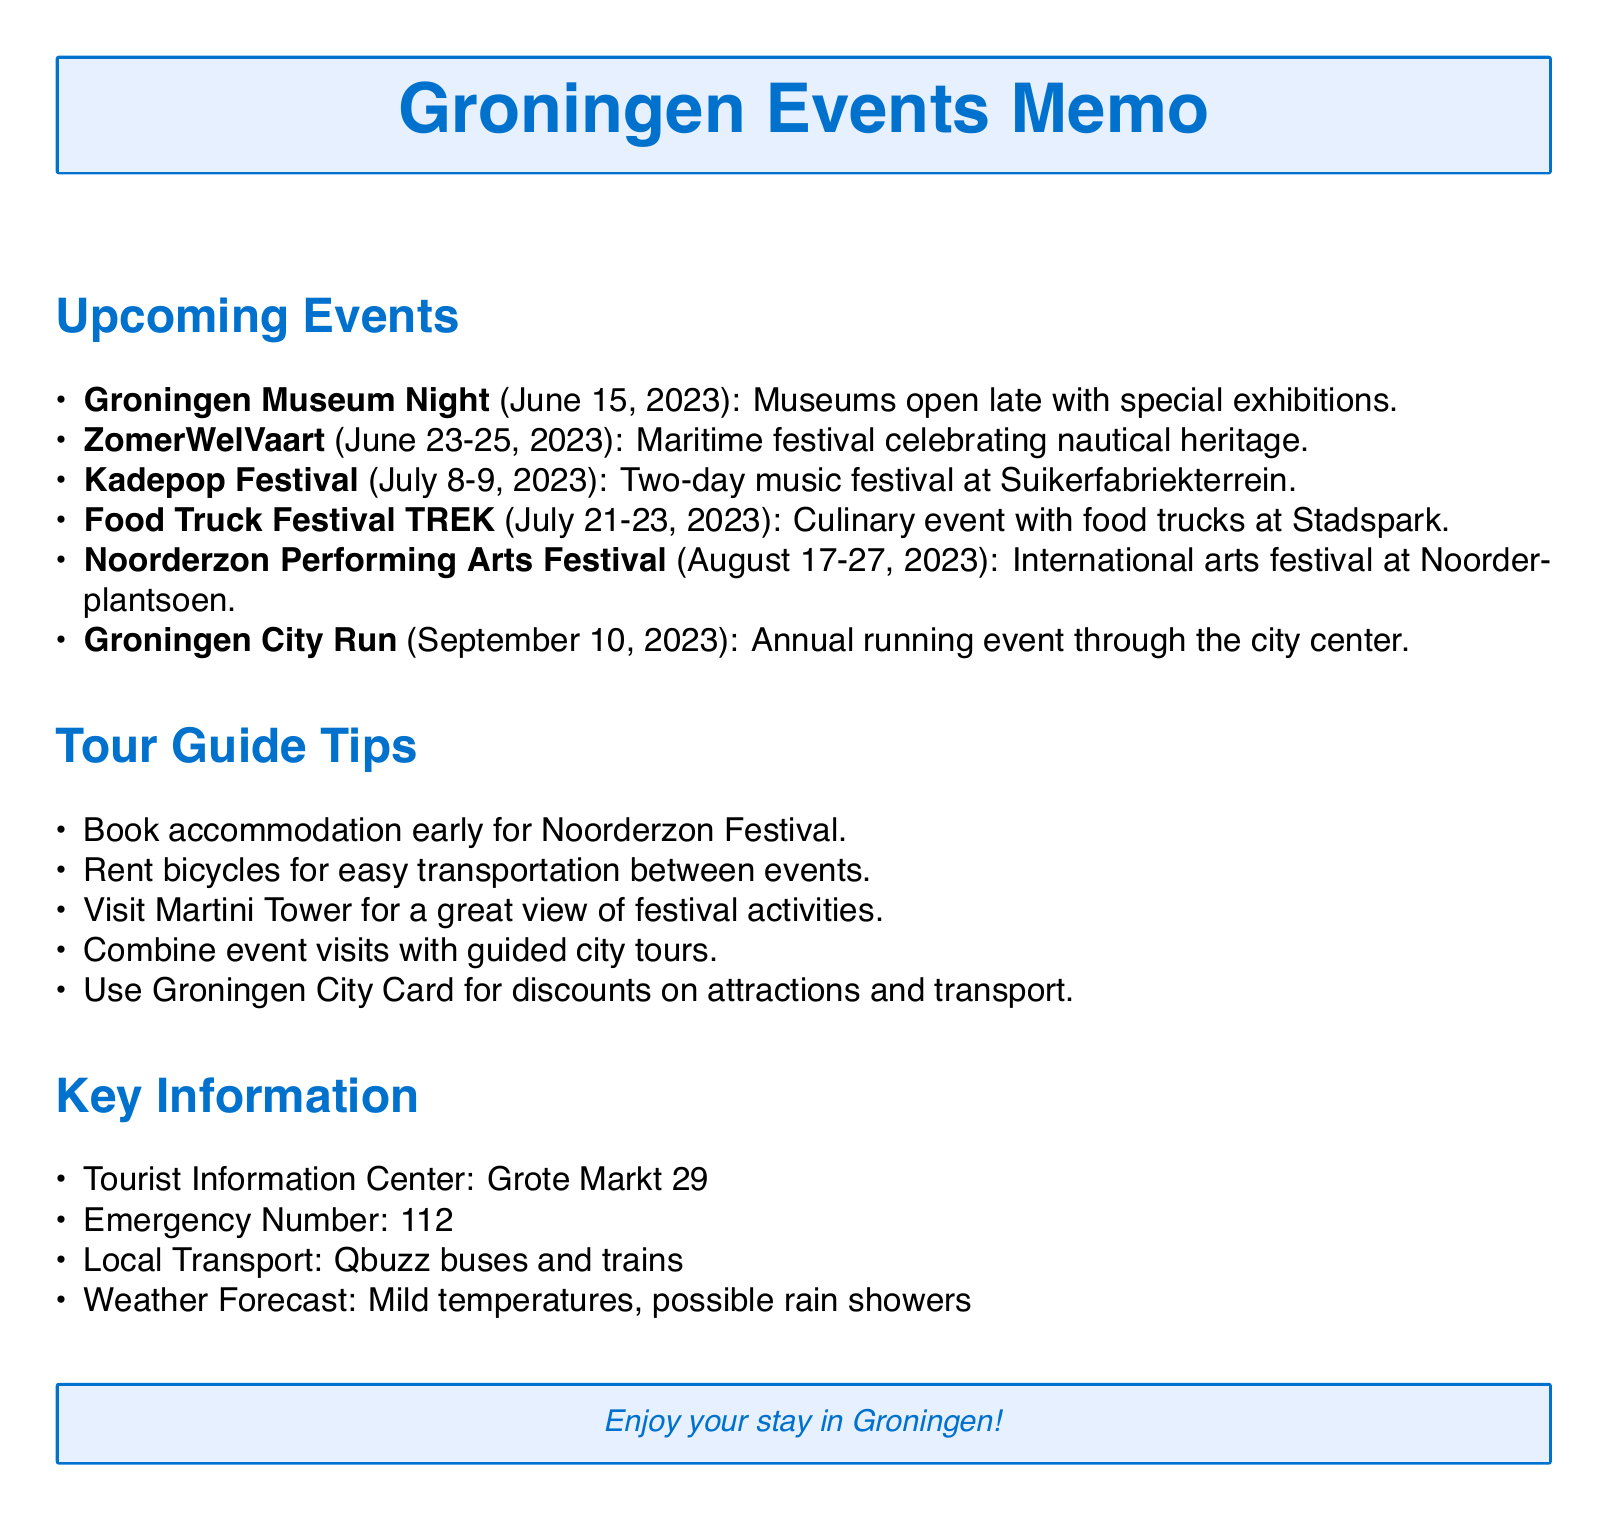What is the date of the Groningen Museum Night? The date is specified in the upcoming events section of the document.
Answer: June 15, 2023 What is the venue for the Noorderzon Performing Arts Festival? The venue is mentioned in the description of the festival in the document.
Answer: Noorderplantsoen Which event features a variety of food trucks? The event description outlines the culinary aspect of the festival.
Answer: Food Truck Festival TREK How long does the Kadepop Festival last? The duration is indicated by the dates provided for the festival in the document.
Answer: Two days What should visitors do early for the Noorderzon Festival according to the tour guide tips? The tips section provides various recommendations for tourists.
Answer: Book accommodation What is the weather forecast mentioned in the key information section? The document states the expected weather conditions during the events.
Answer: Mild temperatures, possible rain showers What is the emergency number listed in the document? Emergency contact information can be found in the key information section.
Answer: 112 Where is the Tourist Information Center located? The location is provided under key information in the document.
Answer: Grote Markt 29 What kind of transportation does the local transport section refer to? The document specifies the types of transport available for visitors.
Answer: Qbuzz buses and trains 